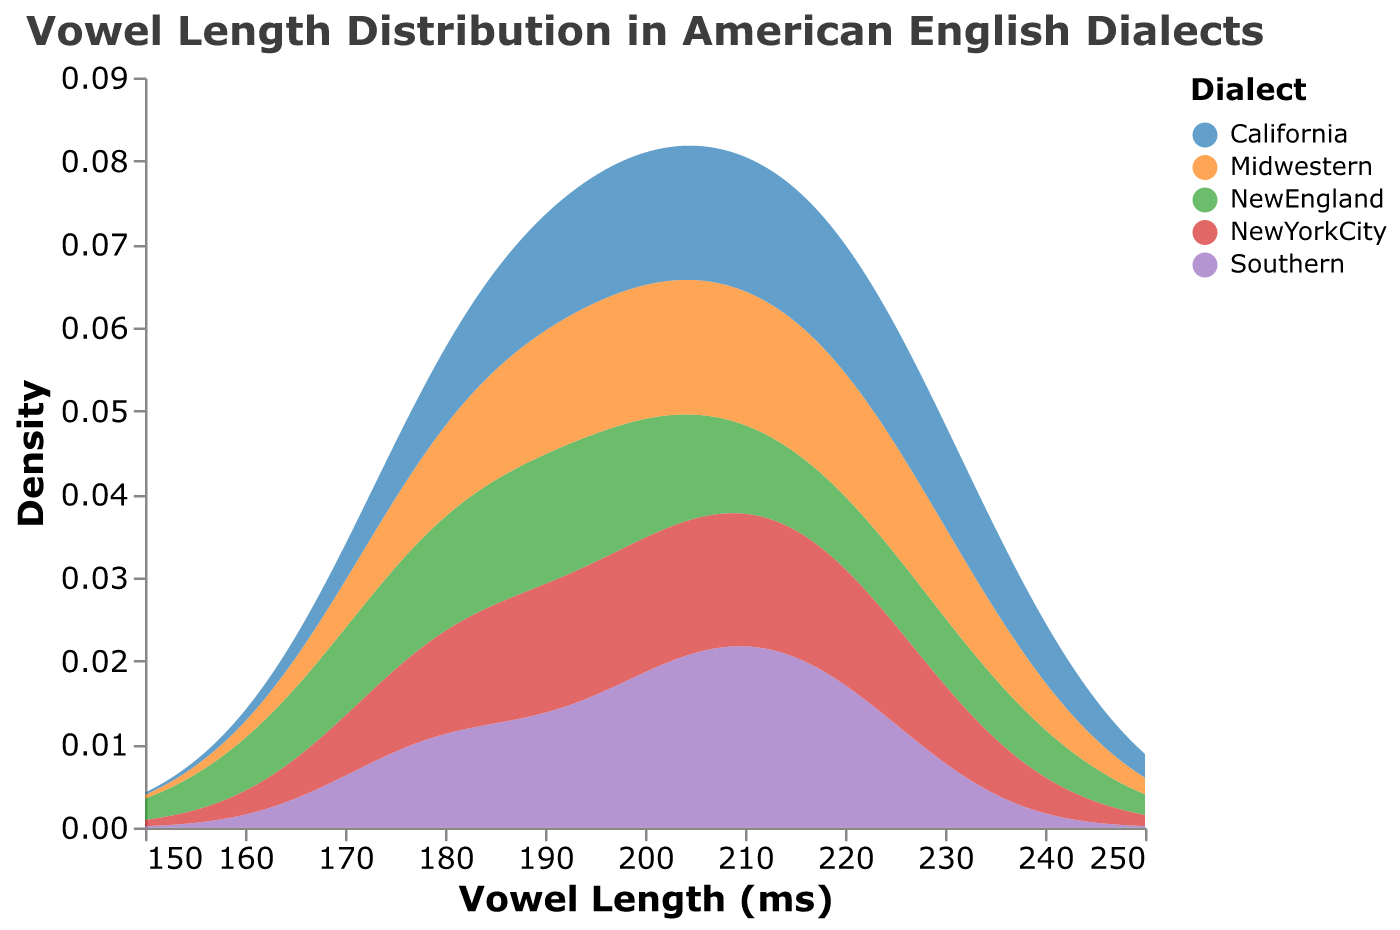How many different dialects are represented in the plot? The legend of the plot shows the color categories, each representing a different dialect. Counting these categories will give us the number of dialects.
Answer: 5 What is the title of the plot? The title of a plot is usually found at the top and provides a summary of what the plot is about.
Answer: "Vowel Length Distribution in American English Dialects" Which dialect has the highest density value at the longest vowel length? Look for the peak density value at the far right of the x-axis (longest vowel length) and identify the corresponding color, then refer to the legend to find the dialect.
Answer: New England Do Monophthongs or Diphthongs have generally longer vowel lengths? Analyze the density distributions; longer vowel lengths will generally show higher density areas on the right side of the plot.
Answer: Diphthongs Which dialect has the lowest density peak for vowel lengths close to 200 ms? Examine the peaks around 200 ms on the x-axis and determine which peak is the lowest by comparing their heights, then check the corresponding color in the legend to identify the dialect.
Answer: New York City Are there more dialects with their peak density value above or below 200 ms? Compare the number of density peaks above and below the 200 ms mark on the x-axis and count the peaks accordingly.
Answer: Below 200 ms What is the approximate range of vowel lengths covered in the plot? Look at the extent of the x-axis from left to right to determine the minimum and maximum vowel lengths displayed.
Answer: 150 ms to 250 ms Which dialect has the most spread-out vowel length distribution? Identify the density plot with the widest range on the x-axis, indicating more variability in vowel lengths.
Answer: Southern Do any dialects overlap significantly in their vowel length density distributions? Check if any density plots have significant overlapping areas and identify the corresponding colors and dialects.
Answer: Yes 